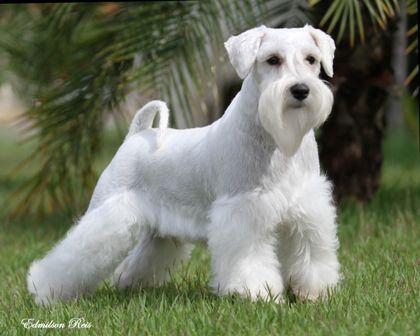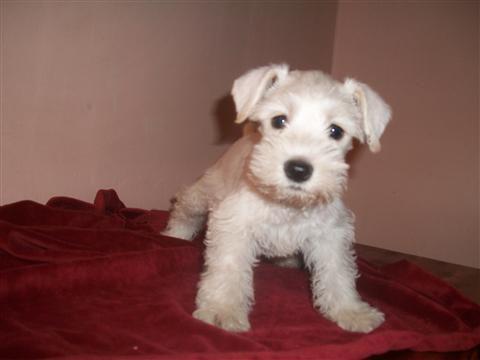The first image is the image on the left, the second image is the image on the right. Assess this claim about the two images: "There is a dog on grass in one of the iamges". Correct or not? Answer yes or no. Yes. 